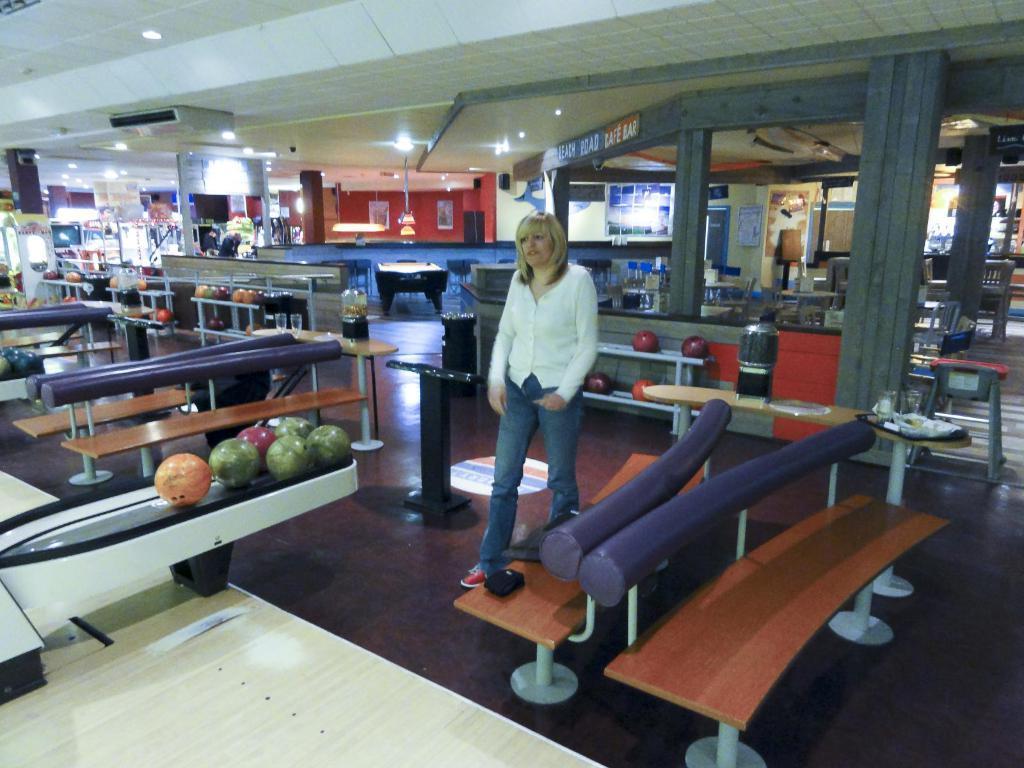Can you describe this image briefly? In this image a lady is standing in a bowling court. She is wearing white shirt. There are chairs beside her. Behind her there are many shops. This is looking like this is inside a mall. 